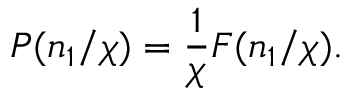Convert formula to latex. <formula><loc_0><loc_0><loc_500><loc_500>P ( n _ { 1 } / \chi ) = \frac { 1 } { \chi } F ( n _ { 1 } / \chi ) .</formula> 